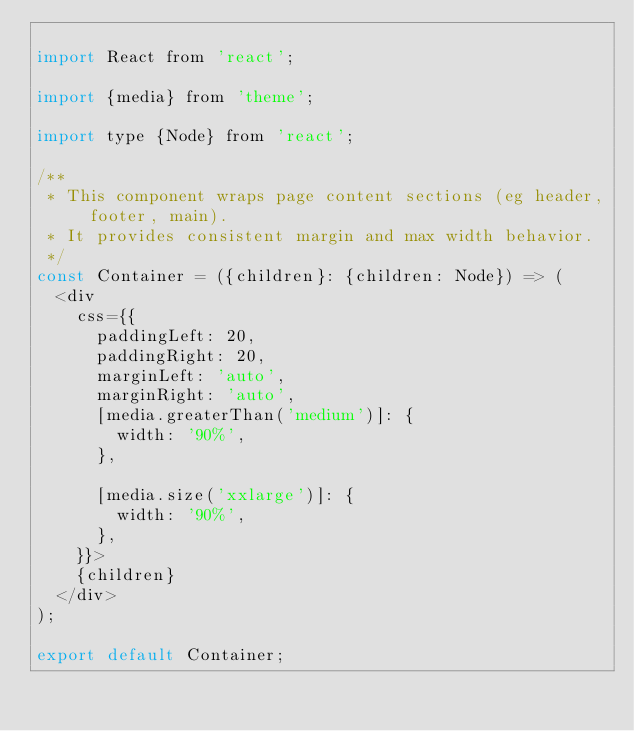Convert code to text. <code><loc_0><loc_0><loc_500><loc_500><_JavaScript_>
import React from 'react';

import {media} from 'theme';

import type {Node} from 'react';

/**
 * This component wraps page content sections (eg header, footer, main).
 * It provides consistent margin and max width behavior.
 */
const Container = ({children}: {children: Node}) => (
  <div
    css={{
      paddingLeft: 20,
      paddingRight: 20,
      marginLeft: 'auto',
      marginRight: 'auto',
      [media.greaterThan('medium')]: {
        width: '90%',
      },

      [media.size('xxlarge')]: {
        width: '90%',
      },
    }}>
    {children}
  </div>
);

export default Container;
</code> 